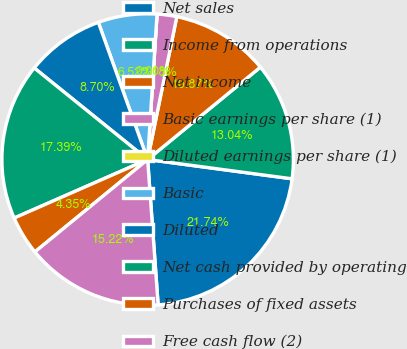Convert chart. <chart><loc_0><loc_0><loc_500><loc_500><pie_chart><fcel>Net sales<fcel>Income from operations<fcel>Net income<fcel>Basic earnings per share (1)<fcel>Diluted earnings per share (1)<fcel>Basic<fcel>Diluted<fcel>Net cash provided by operating<fcel>Purchases of fixed assets<fcel>Free cash flow (2)<nl><fcel>21.74%<fcel>13.04%<fcel>10.87%<fcel>2.18%<fcel>0.0%<fcel>6.52%<fcel>8.7%<fcel>17.39%<fcel>4.35%<fcel>15.22%<nl></chart> 